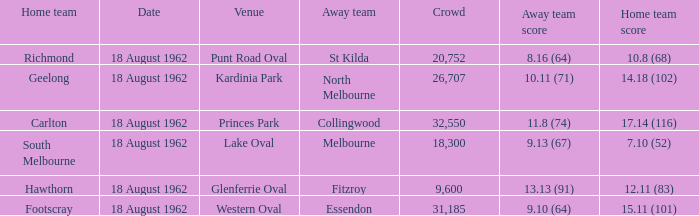What was the home team that scored 10.8 (68)? Richmond. 